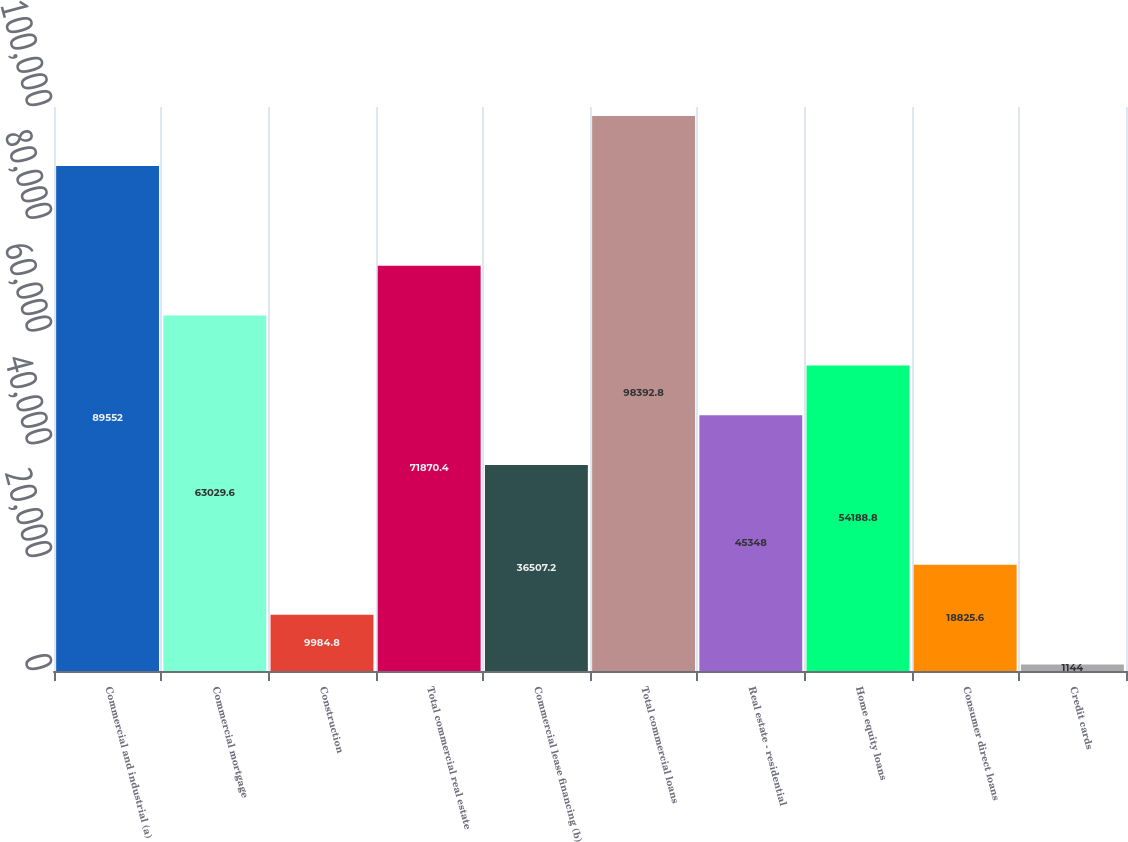Convert chart. <chart><loc_0><loc_0><loc_500><loc_500><bar_chart><fcel>Commercial and industrial (a)<fcel>Commercial mortgage<fcel>Construction<fcel>Total commercial real estate<fcel>Commercial lease financing (b)<fcel>Total commercial loans<fcel>Real estate - residential<fcel>Home equity loans<fcel>Consumer direct loans<fcel>Credit cards<nl><fcel>89552<fcel>63029.6<fcel>9984.8<fcel>71870.4<fcel>36507.2<fcel>98392.8<fcel>45348<fcel>54188.8<fcel>18825.6<fcel>1144<nl></chart> 